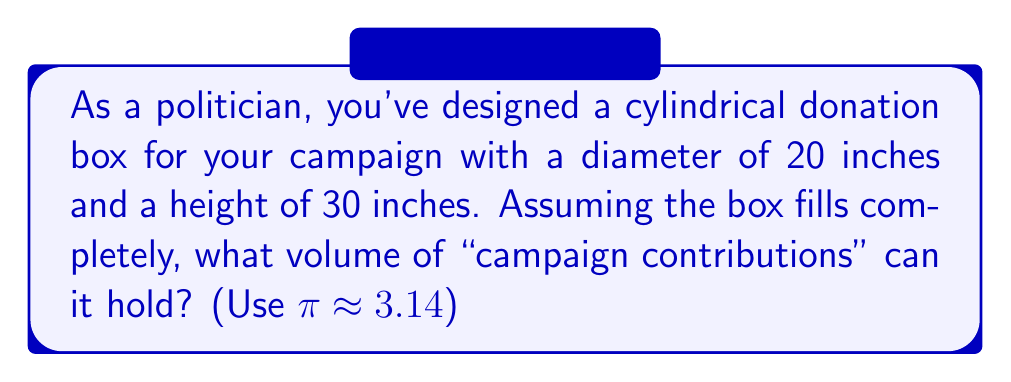Provide a solution to this math problem. To find the volume of a cylindrical donation box, we need to use the formula for the volume of a cylinder:

$$V = \pi r^2 h$$

Where:
$V$ = volume
$r$ = radius of the base
$h$ = height of the cylinder

Given:
- Diameter = 20 inches
- Height = 30 inches
- $\pi \approx 3.14$

Steps:
1. Calculate the radius:
   $r = \frac{\text{diameter}}{2} = \frac{20}{2} = 10$ inches

2. Apply the volume formula:
   $$V = \pi r^2 h$$
   $$V = 3.14 \times 10^2 \times 30$$
   $$V = 3.14 \times 100 \times 30$$
   $$V = 9,420 \text{ cubic inches}$$

3. Round to the nearest whole number:
   $V \approx 9,420 \text{ cubic inches}$

This volume represents the maximum amount of "campaign contributions" the box can hold.
Answer: 9,420 cubic inches 